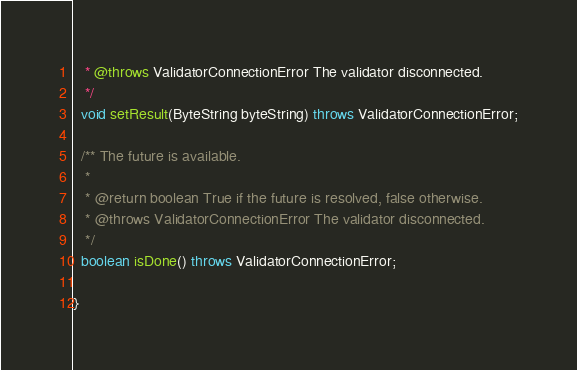Convert code to text. <code><loc_0><loc_0><loc_500><loc_500><_Java_>   * @throws ValidatorConnectionError The validator disconnected.
   */
  void setResult(ByteString byteString) throws ValidatorConnectionError;

  /** The future is available.
   *
   * @return boolean True if the future is resolved, false otherwise.
   * @throws ValidatorConnectionError The validator disconnected.
   */
  boolean isDone() throws ValidatorConnectionError;

}
</code> 